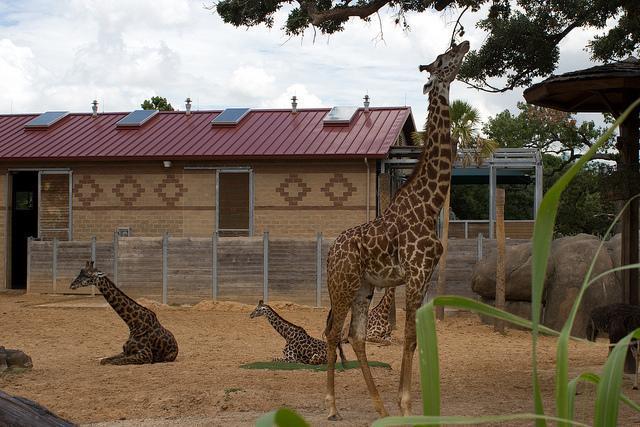How many giraffes are sitting?
Give a very brief answer. 3. How many baby giraffes are pictured?
Give a very brief answer. 2. How many animals in this photo?
Give a very brief answer. 4. How many children are in the picture?
Give a very brief answer. 0. How many giraffes are there?
Give a very brief answer. 4. How many animals are there?
Give a very brief answer. 3. How many doors make one door?
Give a very brief answer. 1. How many giraffes?
Give a very brief answer. 4. How many species are in this picture?
Give a very brief answer. 1. How many giraffes can be seen?
Give a very brief answer. 2. How many people are wearing white shirt?
Give a very brief answer. 0. 